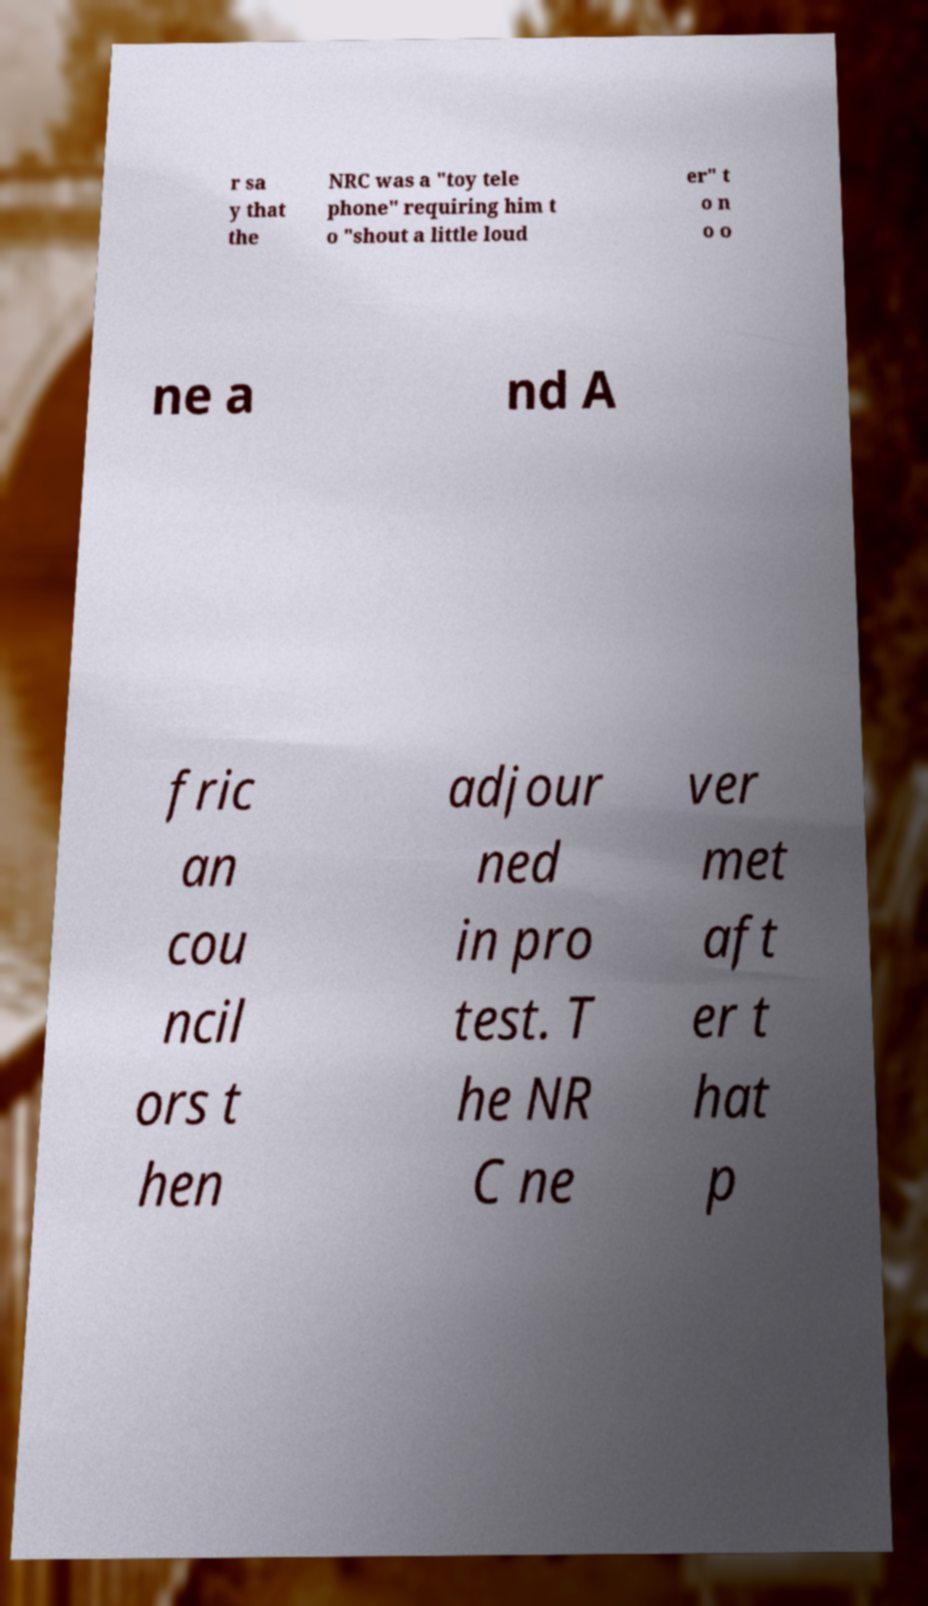Can you read and provide the text displayed in the image?This photo seems to have some interesting text. Can you extract and type it out for me? r sa y that the NRC was a "toy tele phone" requiring him t o "shout a little loud er" t o n o o ne a nd A fric an cou ncil ors t hen adjour ned in pro test. T he NR C ne ver met aft er t hat p 